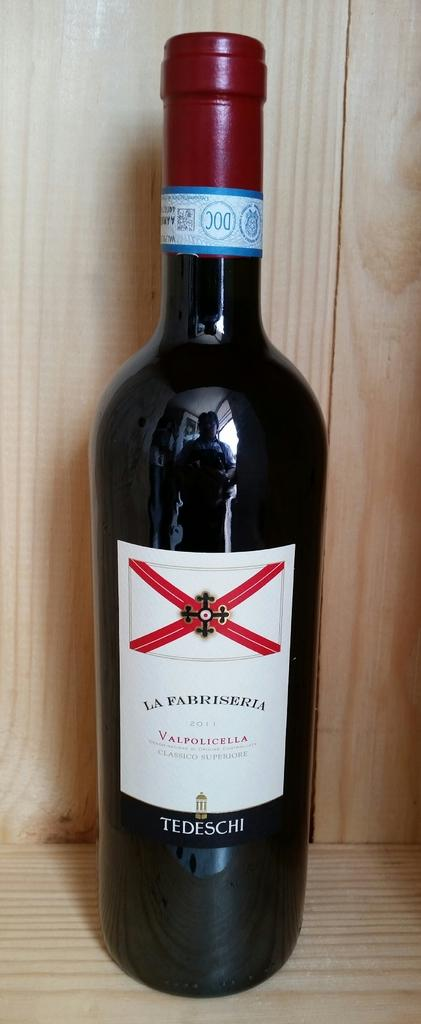<image>
Present a compact description of the photo's key features. A bottle of La Fabriseria wine made in 2011 made by Tedeschi wines. 